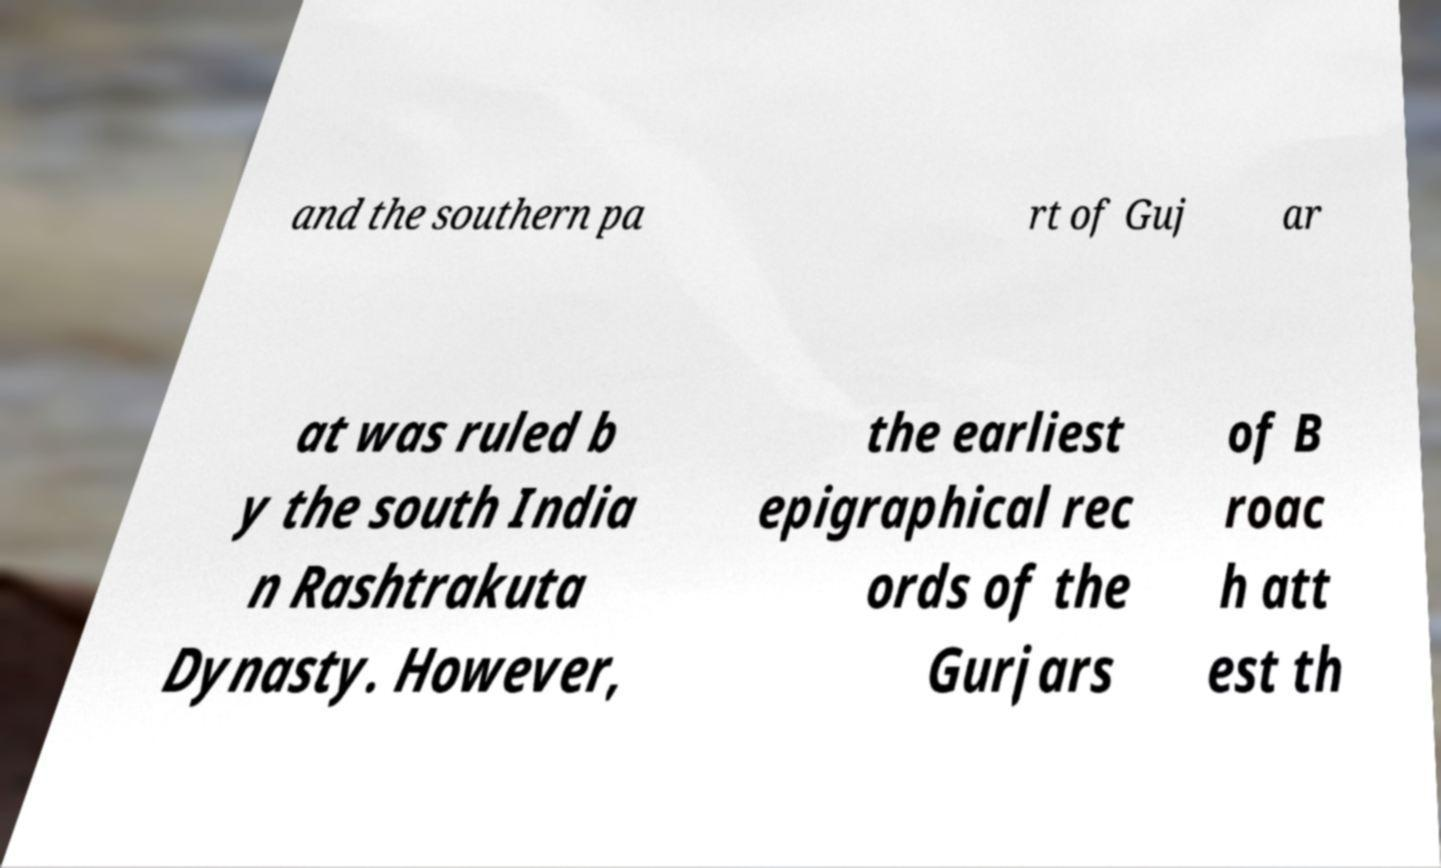Could you assist in decoding the text presented in this image and type it out clearly? and the southern pa rt of Guj ar at was ruled b y the south India n Rashtrakuta Dynasty. However, the earliest epigraphical rec ords of the Gurjars of B roac h att est th 